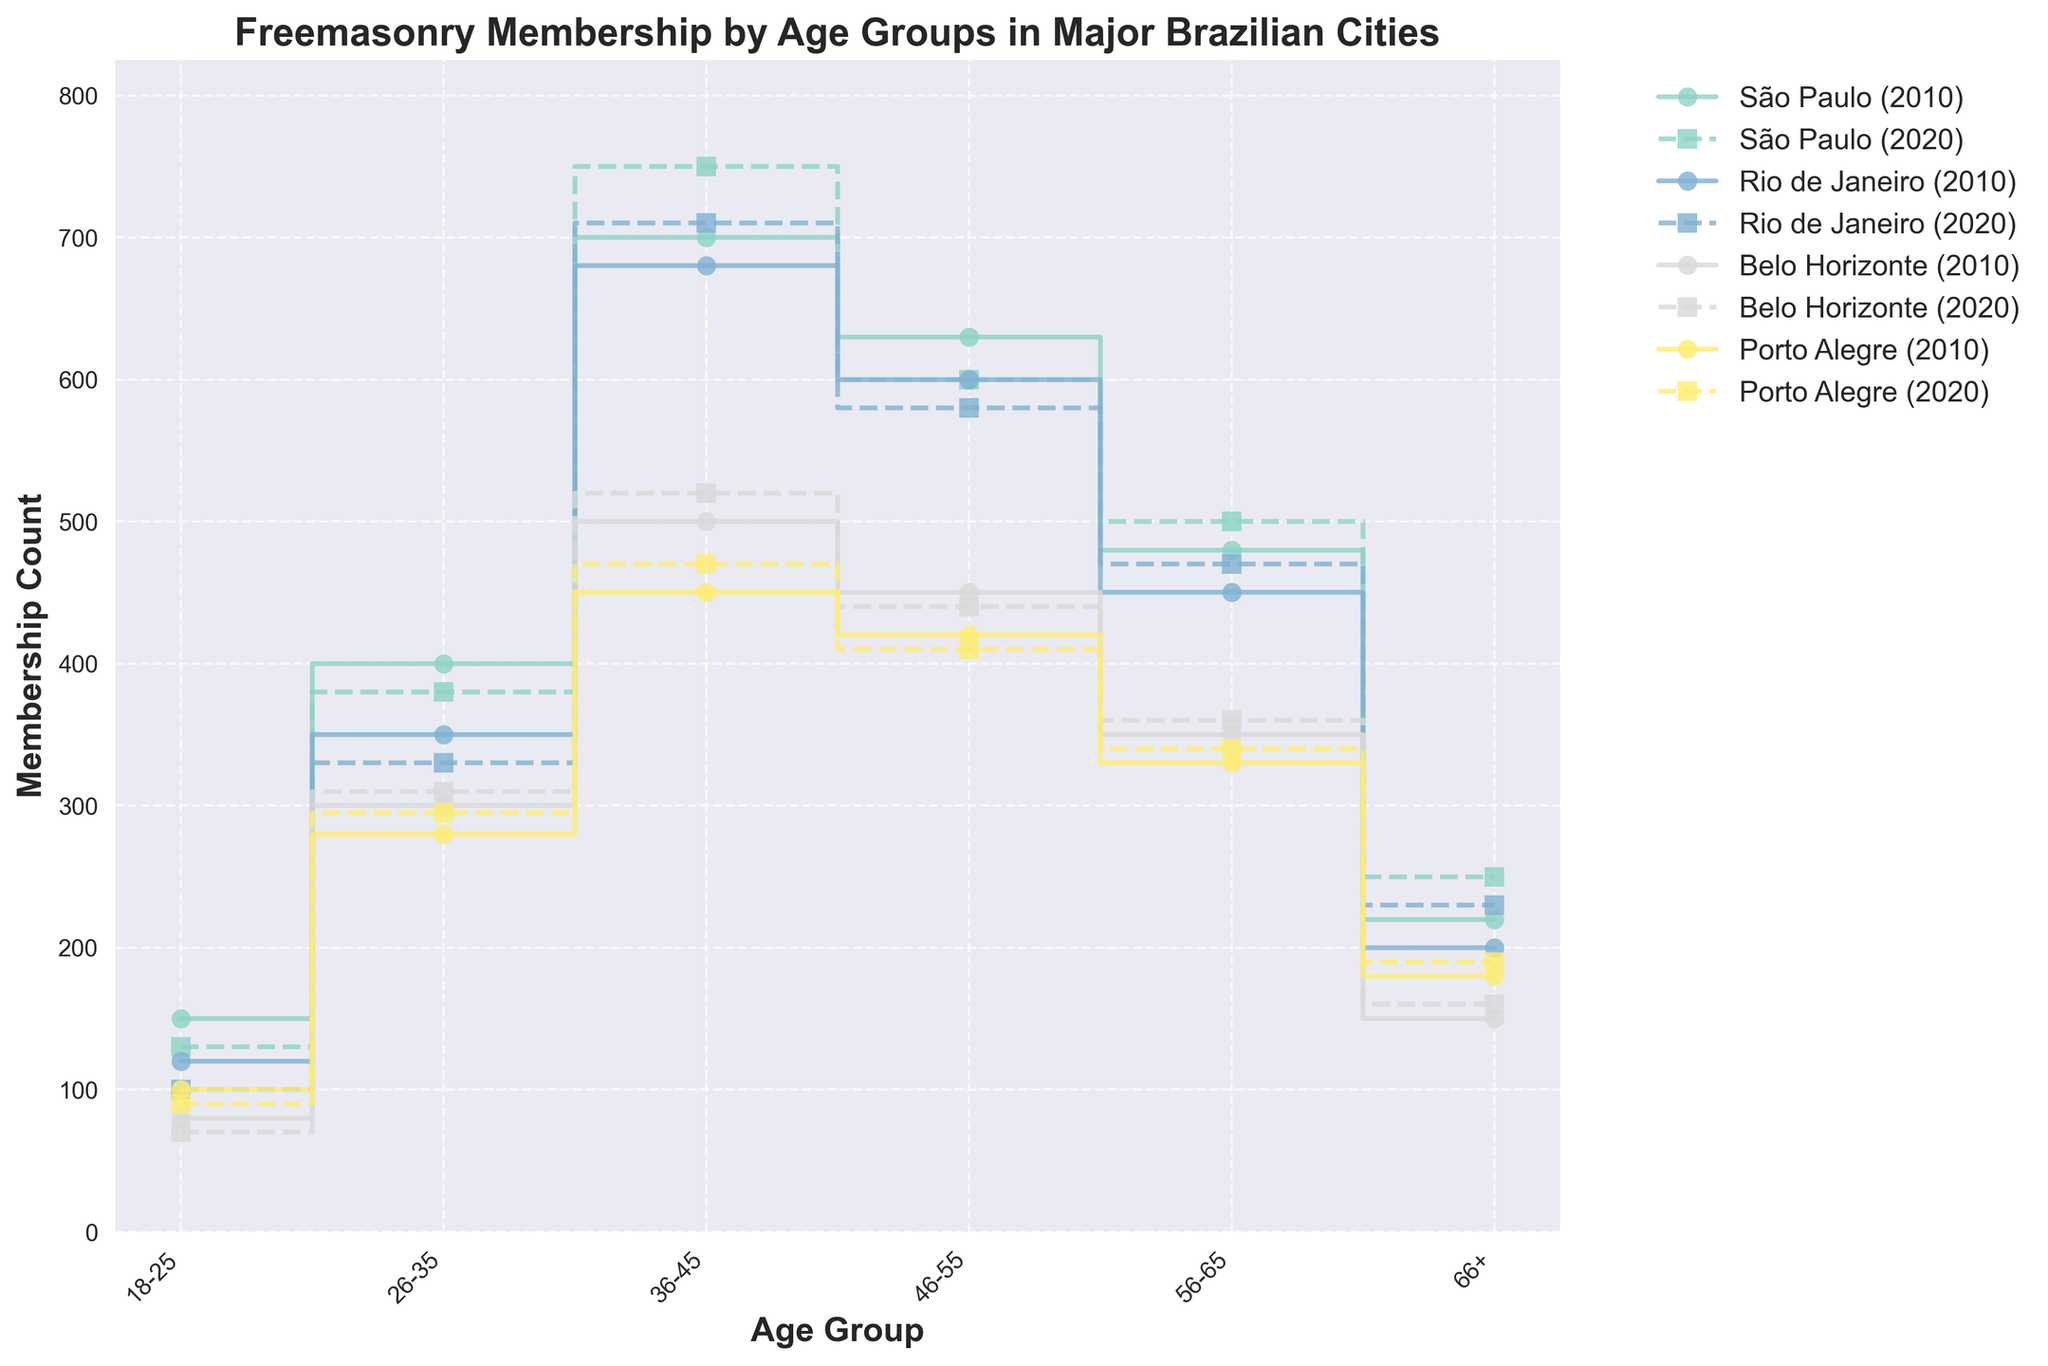What's the title of the plot? The title of the plot is located at the top of the figure. It reads "Freemasonry Membership by Age Groups in Major Brazilian Cities".
Answer: Freemasonry Membership by Age Groups in Major Brazilian Cities What are the x and y axes labeled? The x-axis is labeled "Age Group" and the y-axis is labeled "Membership Count". These labels are located along their respective axes.
Answer: Age Group, Membership Count Which age group in São Paulo had the highest membership count in 2020? To determine this, you need to look at the dashed line marked "São Paulo (2020)" and find the highest point along the y-axis. The highest membership count in 2020 for São Paulo is in the 36-45 age group.
Answer: 36-45 What age group had the lowest membership count in Rio de Janeiro for both years? You need to look at both the solid and dashed lines for Rio de Janeiro in the plot and identify the age group with the lowest membership count for each. The 18-25 age group is the lowest for both years.
Answer: 18-25 How did the membership count for the 18-25 age group in Belo Horizonte change from 2010 to 2020? To find this, compare the height of the "Belo Horizonte" line for the 18-25 age group between the solid line (2010) and the dashed line (2020). The membership count decreased from 80 in 2010 to 70 in 2020.
Answer: Decreased by 10 Which city had the highest total membership count across all age groups in 2010? To determine this, sum the membership counts for all age groups for each city in 2010. For São Paulo: 150 + 400 + 700 + 630 + 480 + 220 = 2580; For Rio de Janeiro: 120 + 350 + 680 + 600 + 450 + 200 = 2400; For Belo Horizonte: 80 + 300 + 500 + 450 + 350 + 150 = 1830; For Porto Alegre: 100 + 280 + 450 + 420 + 330 + 180 = 1760. São Paulo had the highest total.
Answer: São Paulo Did the membership count for the 56-65 age group increase or decrease in Porto Alegre from 2010 to 2020? Compare the 56-65 age group on the Porto Alegre line, noting the values in 2010 and 2020. The count increased from 330 in 2010 to 340 in 2020.
Answer: Increased by 10 Which age group has a noticeable trend of increasing membership over time across most cities? To identify this, observe multiple age groups over time (comparing the solid and dashed lines) across different cities. The 36-45 age group shows a consistent trend of increasing membership over time in most cities.
Answer: 36-45 